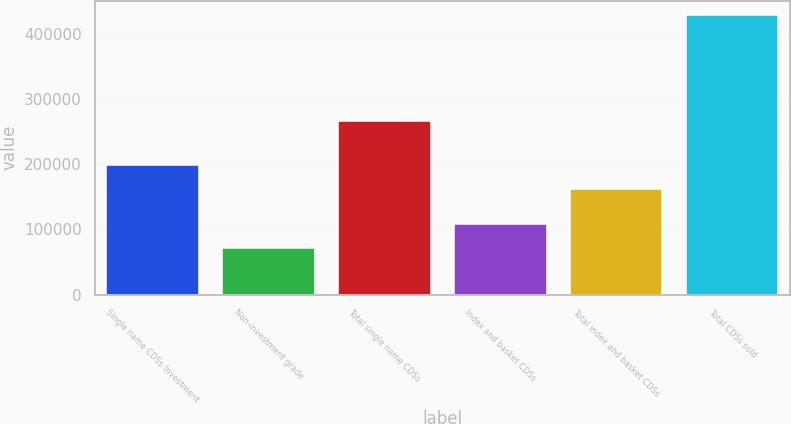<chart> <loc_0><loc_0><loc_500><loc_500><bar_chart><fcel>Single name CDSs Investment<fcel>Non-investment grade<fcel>Total single name CDSs<fcel>Index and basket CDSs<fcel>Total index and basket CDSs<fcel>Total CDSs sold<nl><fcel>198600<fcel>71851<fcel>266918<fcel>107639<fcel>162812<fcel>429730<nl></chart> 